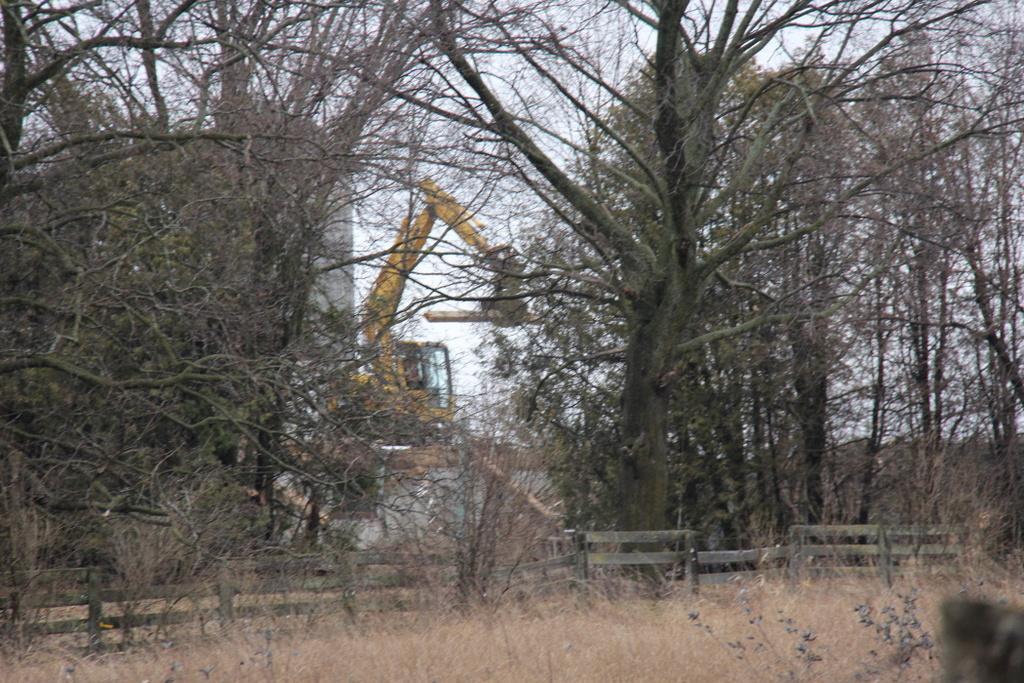How would you summarize this image in a sentence or two? Here we can see grass,fence and trees. In the background there is a excavator,building and sky. 